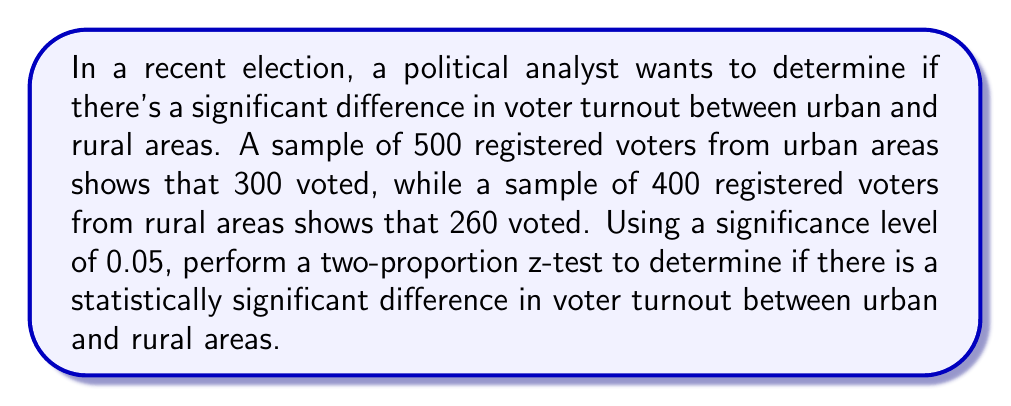Provide a solution to this math problem. To analyze this voting pattern using statistical methods, we'll perform a two-proportion z-test. This test is appropriate when comparing two population proportions.

Step 1: State the null and alternative hypotheses
$H_0: p_1 = p_2$ (no difference in proportions)
$H_a: p_1 \neq p_2$ (there is a difference in proportions)

Where $p_1$ is the proportion of urban voters and $p_2$ is the proportion of rural voters.

Step 2: Calculate the sample proportions
$\hat{p}_1 = \frac{300}{500} = 0.6$ (urban)
$\hat{p}_2 = \frac{260}{400} = 0.65$ (rural)

Step 3: Calculate the pooled sample proportion
$$\hat{p} = \frac{X_1 + X_2}{n_1 + n_2} = \frac{300 + 260}{500 + 400} = \frac{560}{900} = 0.6222$$

Step 4: Calculate the standard error
$$SE = \sqrt{\hat{p}(1-\hat{p})(\frac{1}{n_1} + \frac{1}{n_2})}$$
$$SE = \sqrt{0.6222(1-0.6222)(\frac{1}{500} + \frac{1}{400})} = 0.0336$$

Step 5: Calculate the z-statistic
$$z = \frac{\hat{p}_1 - \hat{p}_2}{SE} = \frac{0.6 - 0.65}{0.0336} = -1.4881$$

Step 6: Determine the critical value
For a two-tailed test at α = 0.05, the critical z-value is ±1.96.

Step 7: Make a decision
Since |-1.4881| < 1.96, we fail to reject the null hypothesis.

Step 8: Calculate the p-value
The p-value for a two-tailed test is:
$$p-value = 2 * P(Z > |-1.4881|) = 2 * 0.0683 = 0.1366$$

This p-value is greater than our significance level of 0.05, confirming our decision to fail to reject the null hypothesis.
Answer: Fail to reject the null hypothesis. There is not enough evidence to conclude that there is a statistically significant difference in voter turnout between urban and rural areas (z = -1.4881, p = 0.1366 > 0.05). 